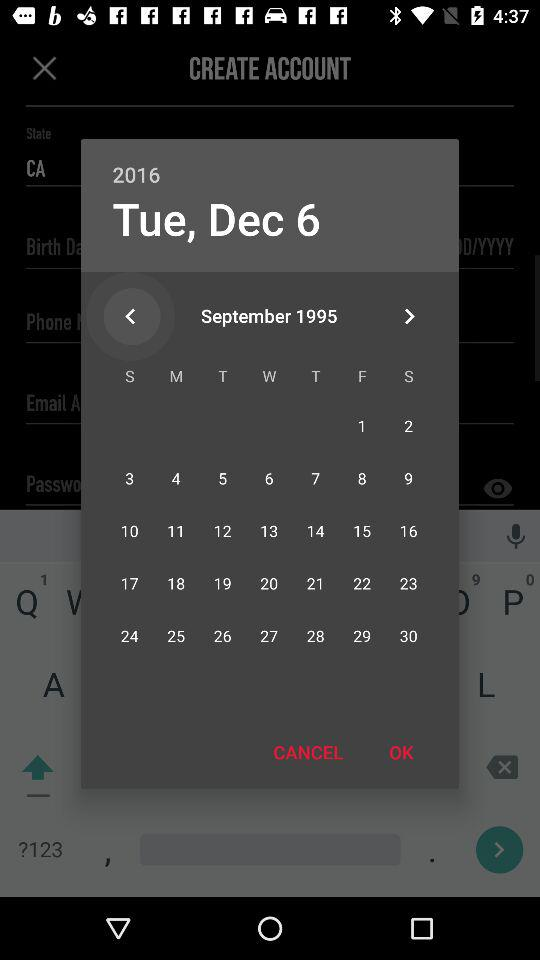Which day falls on September 15, 1995? The day that falls on September 15, 1995 is Friday. 